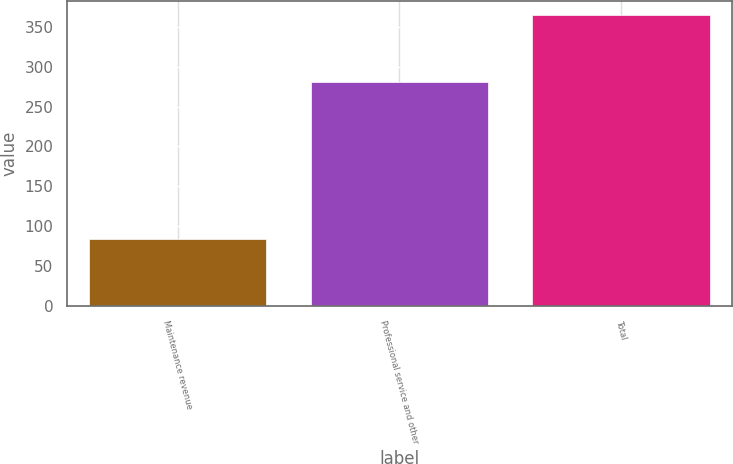<chart> <loc_0><loc_0><loc_500><loc_500><bar_chart><fcel>Maintenance revenue<fcel>Professional service and other<fcel>Total<nl><fcel>84.1<fcel>280.8<fcel>364.9<nl></chart> 